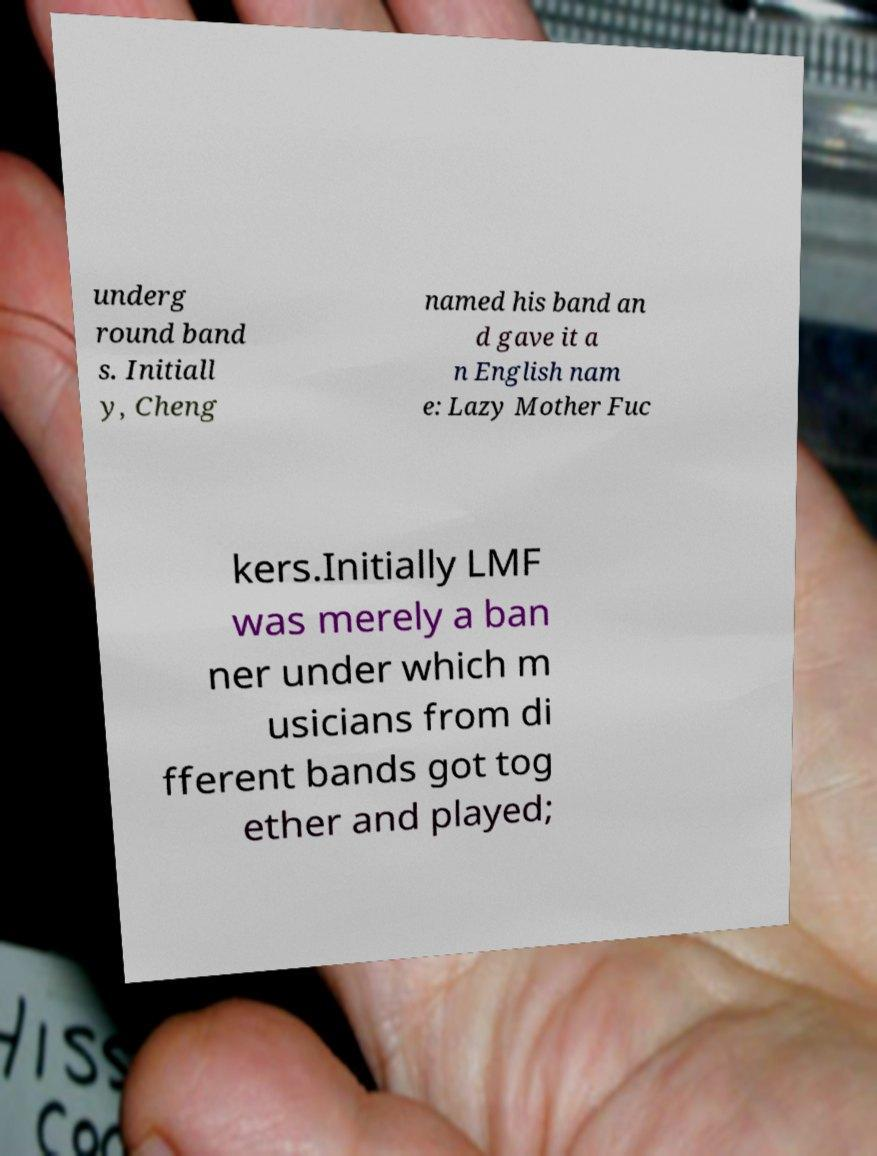Please identify and transcribe the text found in this image. underg round band s. Initiall y, Cheng named his band an d gave it a n English nam e: Lazy Mother Fuc kers.Initially LMF was merely a ban ner under which m usicians from di fferent bands got tog ether and played; 